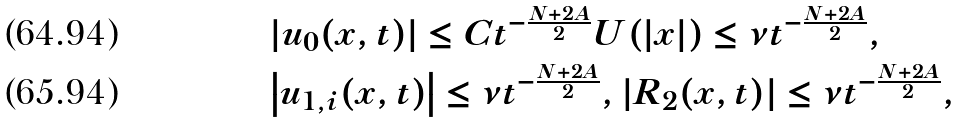<formula> <loc_0><loc_0><loc_500><loc_500>& \left | u _ { 0 } ( x , t ) \right | \leq C t ^ { - \frac { N + 2 A } { 2 } } U ( | x | ) \leq \nu t ^ { - \frac { N + 2 A } { 2 } } , \\ & \left | u _ { 1 , i } ( x , t ) \right | \leq \nu t ^ { - \frac { N + 2 A } { 2 } } , | R _ { 2 } ( x , t ) | \leq \nu t ^ { - \frac { N + 2 A } { 2 } } ,</formula> 